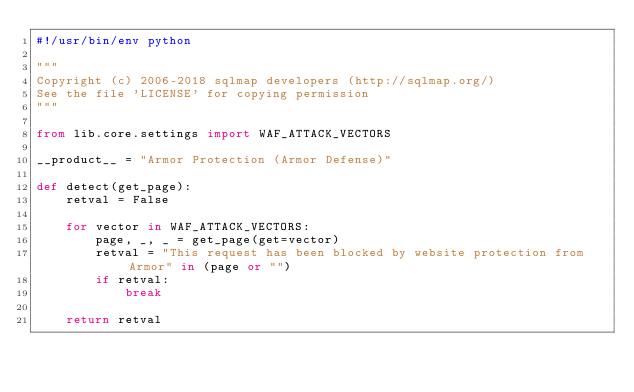<code> <loc_0><loc_0><loc_500><loc_500><_Python_>#!/usr/bin/env python

"""
Copyright (c) 2006-2018 sqlmap developers (http://sqlmap.org/)
See the file 'LICENSE' for copying permission
"""

from lib.core.settings import WAF_ATTACK_VECTORS

__product__ = "Armor Protection (Armor Defense)"

def detect(get_page):
    retval = False

    for vector in WAF_ATTACK_VECTORS:
        page, _, _ = get_page(get=vector)
        retval = "This request has been blocked by website protection from Armor" in (page or "")
        if retval:
            break

    return retval
</code> 